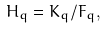<formula> <loc_0><loc_0><loc_500><loc_500>H _ { q } = K _ { q } / F _ { q } ,</formula> 